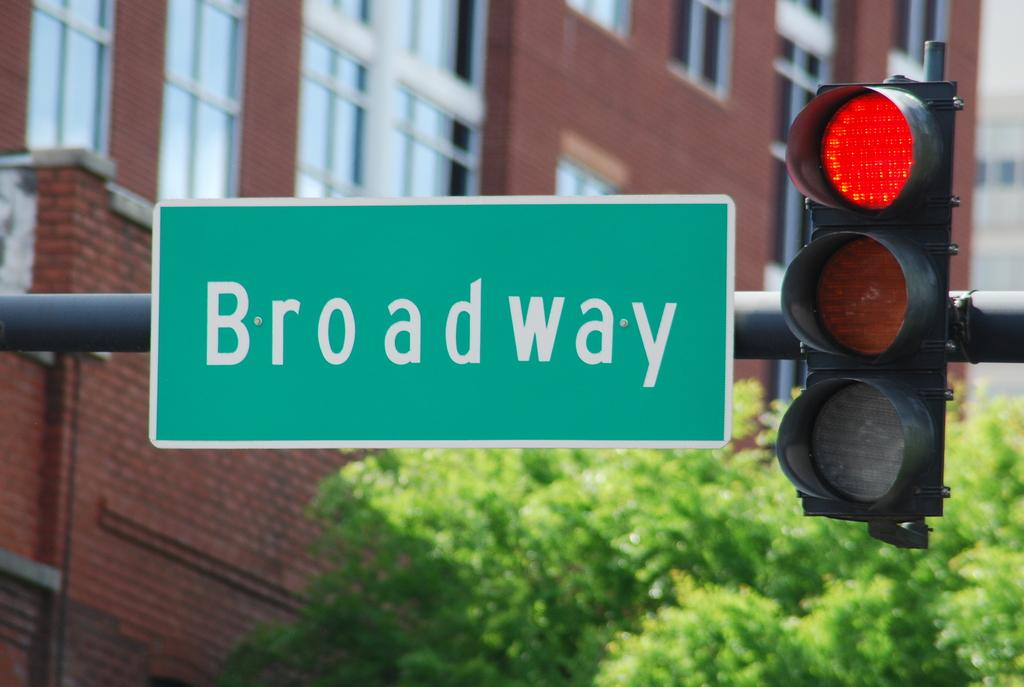<image>
Offer a succinct explanation of the picture presented. The street sign for Broadway is next to the stop light. 